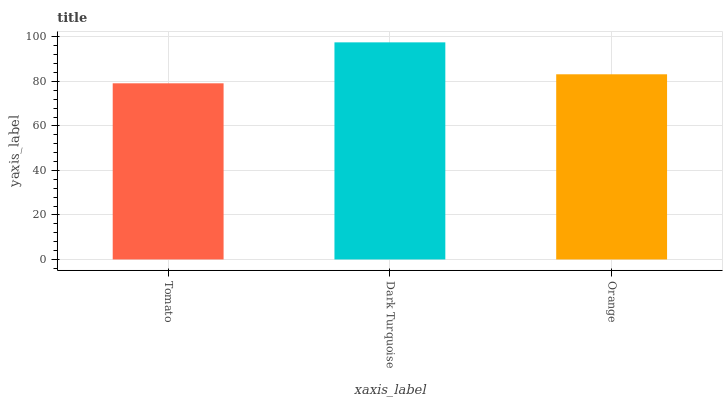Is Tomato the minimum?
Answer yes or no. Yes. Is Dark Turquoise the maximum?
Answer yes or no. Yes. Is Orange the minimum?
Answer yes or no. No. Is Orange the maximum?
Answer yes or no. No. Is Dark Turquoise greater than Orange?
Answer yes or no. Yes. Is Orange less than Dark Turquoise?
Answer yes or no. Yes. Is Orange greater than Dark Turquoise?
Answer yes or no. No. Is Dark Turquoise less than Orange?
Answer yes or no. No. Is Orange the high median?
Answer yes or no. Yes. Is Orange the low median?
Answer yes or no. Yes. Is Dark Turquoise the high median?
Answer yes or no. No. Is Tomato the low median?
Answer yes or no. No. 